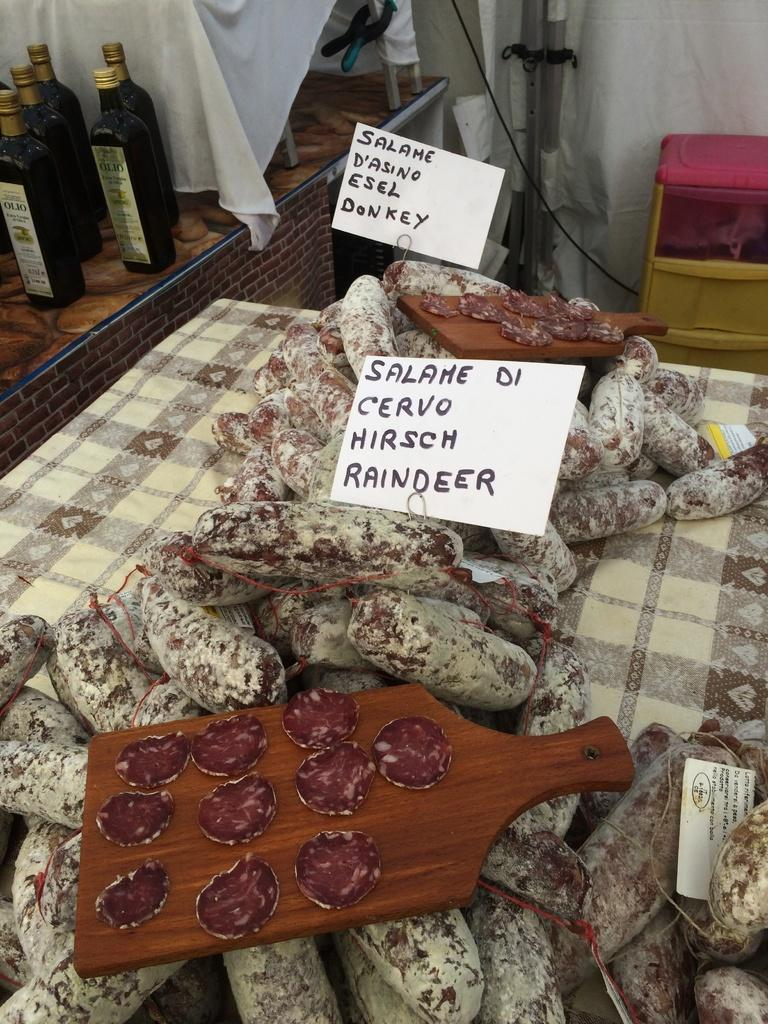<image>
Share a concise interpretation of the image provided. a bunch of salame di cervo on op of a kitchen table. 